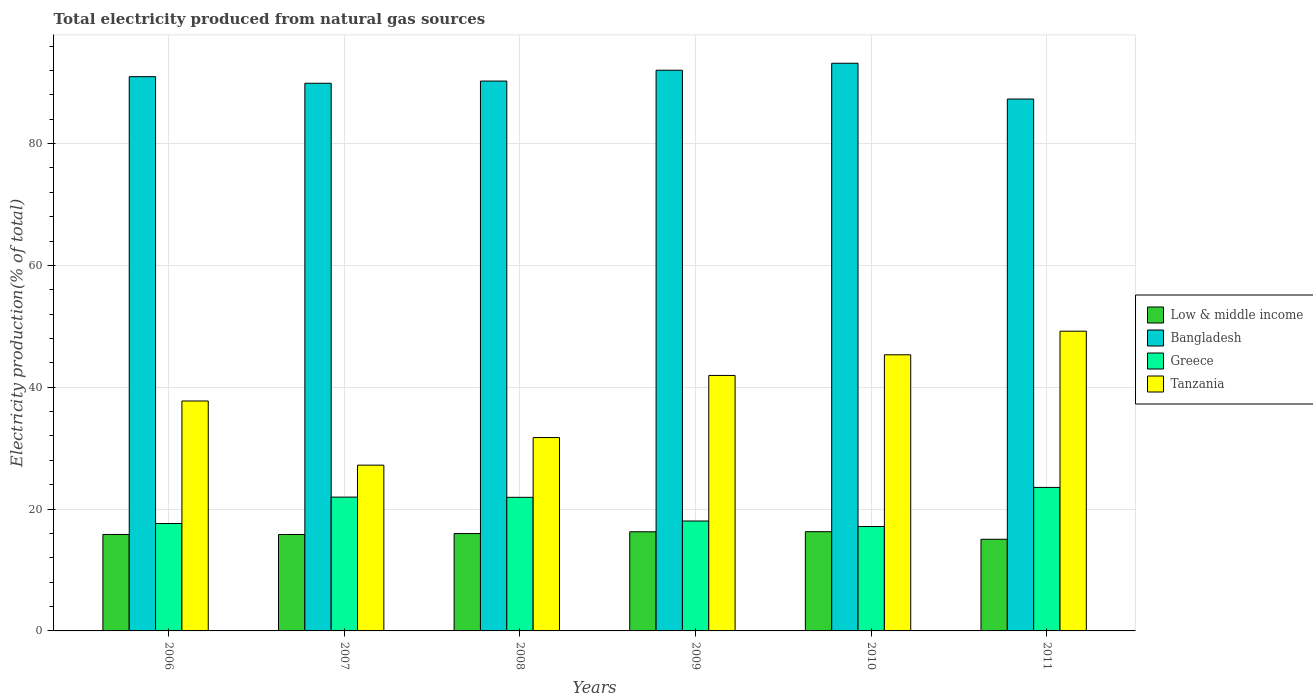How many different coloured bars are there?
Offer a terse response. 4. How many groups of bars are there?
Provide a succinct answer. 6. Are the number of bars per tick equal to the number of legend labels?
Your response must be concise. Yes. Are the number of bars on each tick of the X-axis equal?
Provide a succinct answer. Yes. What is the label of the 4th group of bars from the left?
Provide a short and direct response. 2009. What is the total electricity produced in Low & middle income in 2011?
Make the answer very short. 15.04. Across all years, what is the maximum total electricity produced in Bangladesh?
Give a very brief answer. 93.18. Across all years, what is the minimum total electricity produced in Tanzania?
Provide a succinct answer. 27.21. What is the total total electricity produced in Greece in the graph?
Your response must be concise. 120.26. What is the difference between the total electricity produced in Low & middle income in 2006 and that in 2008?
Keep it short and to the point. -0.15. What is the difference between the total electricity produced in Low & middle income in 2009 and the total electricity produced in Tanzania in 2006?
Your answer should be compact. -21.47. What is the average total electricity produced in Greece per year?
Offer a terse response. 20.04. In the year 2011, what is the difference between the total electricity produced in Bangladesh and total electricity produced in Tanzania?
Provide a short and direct response. 38.11. In how many years, is the total electricity produced in Greece greater than 80 %?
Give a very brief answer. 0. What is the ratio of the total electricity produced in Low & middle income in 2007 to that in 2008?
Give a very brief answer. 0.99. Is the difference between the total electricity produced in Bangladesh in 2009 and 2011 greater than the difference between the total electricity produced in Tanzania in 2009 and 2011?
Give a very brief answer. Yes. What is the difference between the highest and the second highest total electricity produced in Low & middle income?
Your answer should be compact. 0.01. What is the difference between the highest and the lowest total electricity produced in Low & middle income?
Offer a very short reply. 1.25. In how many years, is the total electricity produced in Bangladesh greater than the average total electricity produced in Bangladesh taken over all years?
Keep it short and to the point. 3. Is the sum of the total electricity produced in Greece in 2008 and 2011 greater than the maximum total electricity produced in Tanzania across all years?
Provide a succinct answer. No. What does the 3rd bar from the left in 2006 represents?
Keep it short and to the point. Greece. What does the 1st bar from the right in 2011 represents?
Your answer should be compact. Tanzania. Is it the case that in every year, the sum of the total electricity produced in Low & middle income and total electricity produced in Bangladesh is greater than the total electricity produced in Tanzania?
Offer a terse response. Yes. How many bars are there?
Give a very brief answer. 24. Are all the bars in the graph horizontal?
Provide a short and direct response. No. How many years are there in the graph?
Ensure brevity in your answer.  6. Does the graph contain any zero values?
Make the answer very short. No. Where does the legend appear in the graph?
Your answer should be very brief. Center right. How are the legend labels stacked?
Your answer should be very brief. Vertical. What is the title of the graph?
Offer a terse response. Total electricity produced from natural gas sources. What is the label or title of the X-axis?
Ensure brevity in your answer.  Years. What is the Electricity production(% of total) in Low & middle income in 2006?
Provide a short and direct response. 15.83. What is the Electricity production(% of total) of Bangladesh in 2006?
Your answer should be very brief. 90.98. What is the Electricity production(% of total) in Greece in 2006?
Make the answer very short. 17.63. What is the Electricity production(% of total) of Tanzania in 2006?
Provide a succinct answer. 37.74. What is the Electricity production(% of total) of Low & middle income in 2007?
Your answer should be compact. 15.83. What is the Electricity production(% of total) in Bangladesh in 2007?
Give a very brief answer. 89.9. What is the Electricity production(% of total) in Greece in 2007?
Offer a very short reply. 21.96. What is the Electricity production(% of total) of Tanzania in 2007?
Your response must be concise. 27.21. What is the Electricity production(% of total) of Low & middle income in 2008?
Your answer should be compact. 15.99. What is the Electricity production(% of total) in Bangladesh in 2008?
Keep it short and to the point. 90.26. What is the Electricity production(% of total) of Greece in 2008?
Offer a terse response. 21.93. What is the Electricity production(% of total) of Tanzania in 2008?
Offer a terse response. 31.74. What is the Electricity production(% of total) of Low & middle income in 2009?
Your answer should be very brief. 16.27. What is the Electricity production(% of total) of Bangladesh in 2009?
Offer a very short reply. 92.03. What is the Electricity production(% of total) of Greece in 2009?
Keep it short and to the point. 18.04. What is the Electricity production(% of total) of Tanzania in 2009?
Give a very brief answer. 41.93. What is the Electricity production(% of total) in Low & middle income in 2010?
Provide a succinct answer. 16.29. What is the Electricity production(% of total) in Bangladesh in 2010?
Your response must be concise. 93.18. What is the Electricity production(% of total) in Greece in 2010?
Ensure brevity in your answer.  17.14. What is the Electricity production(% of total) of Tanzania in 2010?
Your answer should be very brief. 45.32. What is the Electricity production(% of total) in Low & middle income in 2011?
Keep it short and to the point. 15.04. What is the Electricity production(% of total) in Bangladesh in 2011?
Provide a succinct answer. 87.31. What is the Electricity production(% of total) in Greece in 2011?
Offer a very short reply. 23.56. What is the Electricity production(% of total) in Tanzania in 2011?
Provide a short and direct response. 49.2. Across all years, what is the maximum Electricity production(% of total) in Low & middle income?
Make the answer very short. 16.29. Across all years, what is the maximum Electricity production(% of total) in Bangladesh?
Your answer should be compact. 93.18. Across all years, what is the maximum Electricity production(% of total) of Greece?
Offer a very short reply. 23.56. Across all years, what is the maximum Electricity production(% of total) of Tanzania?
Provide a short and direct response. 49.2. Across all years, what is the minimum Electricity production(% of total) of Low & middle income?
Your answer should be compact. 15.04. Across all years, what is the minimum Electricity production(% of total) of Bangladesh?
Make the answer very short. 87.31. Across all years, what is the minimum Electricity production(% of total) of Greece?
Keep it short and to the point. 17.14. Across all years, what is the minimum Electricity production(% of total) of Tanzania?
Your answer should be compact. 27.21. What is the total Electricity production(% of total) in Low & middle income in the graph?
Ensure brevity in your answer.  95.25. What is the total Electricity production(% of total) of Bangladesh in the graph?
Give a very brief answer. 543.65. What is the total Electricity production(% of total) in Greece in the graph?
Provide a succinct answer. 120.26. What is the total Electricity production(% of total) in Tanzania in the graph?
Give a very brief answer. 233.15. What is the difference between the Electricity production(% of total) in Low & middle income in 2006 and that in 2007?
Offer a terse response. 0.01. What is the difference between the Electricity production(% of total) in Greece in 2006 and that in 2007?
Give a very brief answer. -4.33. What is the difference between the Electricity production(% of total) in Tanzania in 2006 and that in 2007?
Make the answer very short. 10.53. What is the difference between the Electricity production(% of total) in Low & middle income in 2006 and that in 2008?
Your response must be concise. -0.15. What is the difference between the Electricity production(% of total) of Bangladesh in 2006 and that in 2008?
Offer a terse response. 0.72. What is the difference between the Electricity production(% of total) in Greece in 2006 and that in 2008?
Offer a terse response. -4.3. What is the difference between the Electricity production(% of total) in Tanzania in 2006 and that in 2008?
Offer a very short reply. 6.01. What is the difference between the Electricity production(% of total) of Low & middle income in 2006 and that in 2009?
Your response must be concise. -0.44. What is the difference between the Electricity production(% of total) in Bangladesh in 2006 and that in 2009?
Ensure brevity in your answer.  -1.06. What is the difference between the Electricity production(% of total) of Greece in 2006 and that in 2009?
Offer a terse response. -0.41. What is the difference between the Electricity production(% of total) of Tanzania in 2006 and that in 2009?
Offer a terse response. -4.19. What is the difference between the Electricity production(% of total) in Low & middle income in 2006 and that in 2010?
Offer a terse response. -0.46. What is the difference between the Electricity production(% of total) in Bangladesh in 2006 and that in 2010?
Offer a terse response. -2.2. What is the difference between the Electricity production(% of total) in Greece in 2006 and that in 2010?
Your answer should be compact. 0.5. What is the difference between the Electricity production(% of total) in Tanzania in 2006 and that in 2010?
Your answer should be compact. -7.58. What is the difference between the Electricity production(% of total) of Low & middle income in 2006 and that in 2011?
Make the answer very short. 0.79. What is the difference between the Electricity production(% of total) of Bangladesh in 2006 and that in 2011?
Keep it short and to the point. 3.67. What is the difference between the Electricity production(% of total) in Greece in 2006 and that in 2011?
Ensure brevity in your answer.  -5.92. What is the difference between the Electricity production(% of total) of Tanzania in 2006 and that in 2011?
Provide a short and direct response. -11.46. What is the difference between the Electricity production(% of total) in Low & middle income in 2007 and that in 2008?
Offer a terse response. -0.16. What is the difference between the Electricity production(% of total) in Bangladesh in 2007 and that in 2008?
Make the answer very short. -0.36. What is the difference between the Electricity production(% of total) of Greece in 2007 and that in 2008?
Your answer should be compact. 0.03. What is the difference between the Electricity production(% of total) of Tanzania in 2007 and that in 2008?
Keep it short and to the point. -4.53. What is the difference between the Electricity production(% of total) in Low & middle income in 2007 and that in 2009?
Offer a terse response. -0.45. What is the difference between the Electricity production(% of total) of Bangladesh in 2007 and that in 2009?
Offer a very short reply. -2.14. What is the difference between the Electricity production(% of total) of Greece in 2007 and that in 2009?
Ensure brevity in your answer.  3.92. What is the difference between the Electricity production(% of total) of Tanzania in 2007 and that in 2009?
Provide a short and direct response. -14.72. What is the difference between the Electricity production(% of total) of Low & middle income in 2007 and that in 2010?
Your response must be concise. -0.46. What is the difference between the Electricity production(% of total) in Bangladesh in 2007 and that in 2010?
Provide a succinct answer. -3.28. What is the difference between the Electricity production(% of total) in Greece in 2007 and that in 2010?
Your answer should be very brief. 4.83. What is the difference between the Electricity production(% of total) of Tanzania in 2007 and that in 2010?
Your answer should be very brief. -18.11. What is the difference between the Electricity production(% of total) in Low & middle income in 2007 and that in 2011?
Provide a succinct answer. 0.78. What is the difference between the Electricity production(% of total) in Bangladesh in 2007 and that in 2011?
Your response must be concise. 2.59. What is the difference between the Electricity production(% of total) in Greece in 2007 and that in 2011?
Your answer should be very brief. -1.59. What is the difference between the Electricity production(% of total) of Tanzania in 2007 and that in 2011?
Keep it short and to the point. -21.99. What is the difference between the Electricity production(% of total) in Low & middle income in 2008 and that in 2009?
Ensure brevity in your answer.  -0.29. What is the difference between the Electricity production(% of total) of Bangladesh in 2008 and that in 2009?
Offer a very short reply. -1.78. What is the difference between the Electricity production(% of total) of Greece in 2008 and that in 2009?
Give a very brief answer. 3.89. What is the difference between the Electricity production(% of total) of Tanzania in 2008 and that in 2009?
Give a very brief answer. -10.2. What is the difference between the Electricity production(% of total) in Low & middle income in 2008 and that in 2010?
Your answer should be compact. -0.3. What is the difference between the Electricity production(% of total) of Bangladesh in 2008 and that in 2010?
Ensure brevity in your answer.  -2.92. What is the difference between the Electricity production(% of total) of Greece in 2008 and that in 2010?
Offer a terse response. 4.8. What is the difference between the Electricity production(% of total) of Tanzania in 2008 and that in 2010?
Your response must be concise. -13.59. What is the difference between the Electricity production(% of total) in Low & middle income in 2008 and that in 2011?
Offer a very short reply. 0.94. What is the difference between the Electricity production(% of total) of Bangladesh in 2008 and that in 2011?
Provide a short and direct response. 2.95. What is the difference between the Electricity production(% of total) in Greece in 2008 and that in 2011?
Offer a very short reply. -1.62. What is the difference between the Electricity production(% of total) of Tanzania in 2008 and that in 2011?
Keep it short and to the point. -17.46. What is the difference between the Electricity production(% of total) in Low & middle income in 2009 and that in 2010?
Your response must be concise. -0.01. What is the difference between the Electricity production(% of total) of Bangladesh in 2009 and that in 2010?
Offer a terse response. -1.14. What is the difference between the Electricity production(% of total) in Greece in 2009 and that in 2010?
Ensure brevity in your answer.  0.91. What is the difference between the Electricity production(% of total) in Tanzania in 2009 and that in 2010?
Offer a terse response. -3.39. What is the difference between the Electricity production(% of total) in Low & middle income in 2009 and that in 2011?
Keep it short and to the point. 1.23. What is the difference between the Electricity production(% of total) in Bangladesh in 2009 and that in 2011?
Make the answer very short. 4.73. What is the difference between the Electricity production(% of total) in Greece in 2009 and that in 2011?
Give a very brief answer. -5.51. What is the difference between the Electricity production(% of total) in Tanzania in 2009 and that in 2011?
Provide a succinct answer. -7.26. What is the difference between the Electricity production(% of total) of Low & middle income in 2010 and that in 2011?
Your answer should be very brief. 1.25. What is the difference between the Electricity production(% of total) in Bangladesh in 2010 and that in 2011?
Offer a very short reply. 5.87. What is the difference between the Electricity production(% of total) of Greece in 2010 and that in 2011?
Offer a terse response. -6.42. What is the difference between the Electricity production(% of total) of Tanzania in 2010 and that in 2011?
Provide a succinct answer. -3.87. What is the difference between the Electricity production(% of total) of Low & middle income in 2006 and the Electricity production(% of total) of Bangladesh in 2007?
Give a very brief answer. -74.06. What is the difference between the Electricity production(% of total) in Low & middle income in 2006 and the Electricity production(% of total) in Greece in 2007?
Provide a short and direct response. -6.13. What is the difference between the Electricity production(% of total) of Low & middle income in 2006 and the Electricity production(% of total) of Tanzania in 2007?
Your answer should be very brief. -11.38. What is the difference between the Electricity production(% of total) of Bangladesh in 2006 and the Electricity production(% of total) of Greece in 2007?
Give a very brief answer. 69.01. What is the difference between the Electricity production(% of total) in Bangladesh in 2006 and the Electricity production(% of total) in Tanzania in 2007?
Your answer should be compact. 63.77. What is the difference between the Electricity production(% of total) of Greece in 2006 and the Electricity production(% of total) of Tanzania in 2007?
Give a very brief answer. -9.58. What is the difference between the Electricity production(% of total) of Low & middle income in 2006 and the Electricity production(% of total) of Bangladesh in 2008?
Offer a very short reply. -74.43. What is the difference between the Electricity production(% of total) of Low & middle income in 2006 and the Electricity production(% of total) of Greece in 2008?
Your response must be concise. -6.1. What is the difference between the Electricity production(% of total) of Low & middle income in 2006 and the Electricity production(% of total) of Tanzania in 2008?
Your answer should be very brief. -15.9. What is the difference between the Electricity production(% of total) in Bangladesh in 2006 and the Electricity production(% of total) in Greece in 2008?
Offer a terse response. 69.05. What is the difference between the Electricity production(% of total) in Bangladesh in 2006 and the Electricity production(% of total) in Tanzania in 2008?
Your answer should be very brief. 59.24. What is the difference between the Electricity production(% of total) in Greece in 2006 and the Electricity production(% of total) in Tanzania in 2008?
Ensure brevity in your answer.  -14.11. What is the difference between the Electricity production(% of total) in Low & middle income in 2006 and the Electricity production(% of total) in Bangladesh in 2009?
Offer a terse response. -76.2. What is the difference between the Electricity production(% of total) of Low & middle income in 2006 and the Electricity production(% of total) of Greece in 2009?
Provide a succinct answer. -2.21. What is the difference between the Electricity production(% of total) in Low & middle income in 2006 and the Electricity production(% of total) in Tanzania in 2009?
Make the answer very short. -26.1. What is the difference between the Electricity production(% of total) of Bangladesh in 2006 and the Electricity production(% of total) of Greece in 2009?
Offer a terse response. 72.93. What is the difference between the Electricity production(% of total) of Bangladesh in 2006 and the Electricity production(% of total) of Tanzania in 2009?
Your answer should be very brief. 49.04. What is the difference between the Electricity production(% of total) of Greece in 2006 and the Electricity production(% of total) of Tanzania in 2009?
Make the answer very short. -24.3. What is the difference between the Electricity production(% of total) in Low & middle income in 2006 and the Electricity production(% of total) in Bangladesh in 2010?
Ensure brevity in your answer.  -77.35. What is the difference between the Electricity production(% of total) in Low & middle income in 2006 and the Electricity production(% of total) in Greece in 2010?
Provide a short and direct response. -1.3. What is the difference between the Electricity production(% of total) of Low & middle income in 2006 and the Electricity production(% of total) of Tanzania in 2010?
Your answer should be very brief. -29.49. What is the difference between the Electricity production(% of total) of Bangladesh in 2006 and the Electricity production(% of total) of Greece in 2010?
Make the answer very short. 73.84. What is the difference between the Electricity production(% of total) of Bangladesh in 2006 and the Electricity production(% of total) of Tanzania in 2010?
Your answer should be very brief. 45.65. What is the difference between the Electricity production(% of total) of Greece in 2006 and the Electricity production(% of total) of Tanzania in 2010?
Your answer should be very brief. -27.69. What is the difference between the Electricity production(% of total) in Low & middle income in 2006 and the Electricity production(% of total) in Bangladesh in 2011?
Provide a short and direct response. -71.47. What is the difference between the Electricity production(% of total) of Low & middle income in 2006 and the Electricity production(% of total) of Greece in 2011?
Your answer should be very brief. -7.72. What is the difference between the Electricity production(% of total) in Low & middle income in 2006 and the Electricity production(% of total) in Tanzania in 2011?
Offer a very short reply. -33.37. What is the difference between the Electricity production(% of total) in Bangladesh in 2006 and the Electricity production(% of total) in Greece in 2011?
Your answer should be very brief. 67.42. What is the difference between the Electricity production(% of total) in Bangladesh in 2006 and the Electricity production(% of total) in Tanzania in 2011?
Provide a succinct answer. 41.78. What is the difference between the Electricity production(% of total) of Greece in 2006 and the Electricity production(% of total) of Tanzania in 2011?
Your answer should be very brief. -31.57. What is the difference between the Electricity production(% of total) of Low & middle income in 2007 and the Electricity production(% of total) of Bangladesh in 2008?
Provide a short and direct response. -74.43. What is the difference between the Electricity production(% of total) of Low & middle income in 2007 and the Electricity production(% of total) of Greece in 2008?
Ensure brevity in your answer.  -6.1. What is the difference between the Electricity production(% of total) in Low & middle income in 2007 and the Electricity production(% of total) in Tanzania in 2008?
Offer a terse response. -15.91. What is the difference between the Electricity production(% of total) in Bangladesh in 2007 and the Electricity production(% of total) in Greece in 2008?
Ensure brevity in your answer.  67.97. What is the difference between the Electricity production(% of total) in Bangladesh in 2007 and the Electricity production(% of total) in Tanzania in 2008?
Make the answer very short. 58.16. What is the difference between the Electricity production(% of total) of Greece in 2007 and the Electricity production(% of total) of Tanzania in 2008?
Provide a short and direct response. -9.77. What is the difference between the Electricity production(% of total) in Low & middle income in 2007 and the Electricity production(% of total) in Bangladesh in 2009?
Ensure brevity in your answer.  -76.21. What is the difference between the Electricity production(% of total) of Low & middle income in 2007 and the Electricity production(% of total) of Greece in 2009?
Make the answer very short. -2.22. What is the difference between the Electricity production(% of total) in Low & middle income in 2007 and the Electricity production(% of total) in Tanzania in 2009?
Keep it short and to the point. -26.11. What is the difference between the Electricity production(% of total) of Bangladesh in 2007 and the Electricity production(% of total) of Greece in 2009?
Offer a terse response. 71.85. What is the difference between the Electricity production(% of total) in Bangladesh in 2007 and the Electricity production(% of total) in Tanzania in 2009?
Your answer should be compact. 47.96. What is the difference between the Electricity production(% of total) in Greece in 2007 and the Electricity production(% of total) in Tanzania in 2009?
Your response must be concise. -19.97. What is the difference between the Electricity production(% of total) in Low & middle income in 2007 and the Electricity production(% of total) in Bangladesh in 2010?
Offer a terse response. -77.35. What is the difference between the Electricity production(% of total) in Low & middle income in 2007 and the Electricity production(% of total) in Greece in 2010?
Provide a succinct answer. -1.31. What is the difference between the Electricity production(% of total) of Low & middle income in 2007 and the Electricity production(% of total) of Tanzania in 2010?
Make the answer very short. -29.5. What is the difference between the Electricity production(% of total) in Bangladesh in 2007 and the Electricity production(% of total) in Greece in 2010?
Offer a very short reply. 72.76. What is the difference between the Electricity production(% of total) of Bangladesh in 2007 and the Electricity production(% of total) of Tanzania in 2010?
Give a very brief answer. 44.57. What is the difference between the Electricity production(% of total) of Greece in 2007 and the Electricity production(% of total) of Tanzania in 2010?
Ensure brevity in your answer.  -23.36. What is the difference between the Electricity production(% of total) of Low & middle income in 2007 and the Electricity production(% of total) of Bangladesh in 2011?
Your answer should be compact. -71.48. What is the difference between the Electricity production(% of total) of Low & middle income in 2007 and the Electricity production(% of total) of Greece in 2011?
Make the answer very short. -7.73. What is the difference between the Electricity production(% of total) in Low & middle income in 2007 and the Electricity production(% of total) in Tanzania in 2011?
Your answer should be very brief. -33.37. What is the difference between the Electricity production(% of total) of Bangladesh in 2007 and the Electricity production(% of total) of Greece in 2011?
Your answer should be compact. 66.34. What is the difference between the Electricity production(% of total) of Bangladesh in 2007 and the Electricity production(% of total) of Tanzania in 2011?
Offer a very short reply. 40.7. What is the difference between the Electricity production(% of total) in Greece in 2007 and the Electricity production(% of total) in Tanzania in 2011?
Provide a short and direct response. -27.23. What is the difference between the Electricity production(% of total) of Low & middle income in 2008 and the Electricity production(% of total) of Bangladesh in 2009?
Ensure brevity in your answer.  -76.05. What is the difference between the Electricity production(% of total) in Low & middle income in 2008 and the Electricity production(% of total) in Greece in 2009?
Make the answer very short. -2.06. What is the difference between the Electricity production(% of total) in Low & middle income in 2008 and the Electricity production(% of total) in Tanzania in 2009?
Provide a succinct answer. -25.95. What is the difference between the Electricity production(% of total) in Bangladesh in 2008 and the Electricity production(% of total) in Greece in 2009?
Your response must be concise. 72.22. What is the difference between the Electricity production(% of total) in Bangladesh in 2008 and the Electricity production(% of total) in Tanzania in 2009?
Your answer should be very brief. 48.32. What is the difference between the Electricity production(% of total) of Greece in 2008 and the Electricity production(% of total) of Tanzania in 2009?
Provide a succinct answer. -20. What is the difference between the Electricity production(% of total) of Low & middle income in 2008 and the Electricity production(% of total) of Bangladesh in 2010?
Give a very brief answer. -77.19. What is the difference between the Electricity production(% of total) in Low & middle income in 2008 and the Electricity production(% of total) in Greece in 2010?
Provide a succinct answer. -1.15. What is the difference between the Electricity production(% of total) of Low & middle income in 2008 and the Electricity production(% of total) of Tanzania in 2010?
Your response must be concise. -29.34. What is the difference between the Electricity production(% of total) of Bangladesh in 2008 and the Electricity production(% of total) of Greece in 2010?
Make the answer very short. 73.12. What is the difference between the Electricity production(% of total) of Bangladesh in 2008 and the Electricity production(% of total) of Tanzania in 2010?
Your response must be concise. 44.93. What is the difference between the Electricity production(% of total) of Greece in 2008 and the Electricity production(% of total) of Tanzania in 2010?
Provide a short and direct response. -23.39. What is the difference between the Electricity production(% of total) of Low & middle income in 2008 and the Electricity production(% of total) of Bangladesh in 2011?
Provide a short and direct response. -71.32. What is the difference between the Electricity production(% of total) of Low & middle income in 2008 and the Electricity production(% of total) of Greece in 2011?
Ensure brevity in your answer.  -7.57. What is the difference between the Electricity production(% of total) in Low & middle income in 2008 and the Electricity production(% of total) in Tanzania in 2011?
Provide a short and direct response. -33.21. What is the difference between the Electricity production(% of total) in Bangladesh in 2008 and the Electricity production(% of total) in Greece in 2011?
Your answer should be compact. 66.7. What is the difference between the Electricity production(% of total) of Bangladesh in 2008 and the Electricity production(% of total) of Tanzania in 2011?
Ensure brevity in your answer.  41.06. What is the difference between the Electricity production(% of total) of Greece in 2008 and the Electricity production(% of total) of Tanzania in 2011?
Offer a very short reply. -27.27. What is the difference between the Electricity production(% of total) of Low & middle income in 2009 and the Electricity production(% of total) of Bangladesh in 2010?
Ensure brevity in your answer.  -76.9. What is the difference between the Electricity production(% of total) in Low & middle income in 2009 and the Electricity production(% of total) in Greece in 2010?
Your answer should be very brief. -0.86. What is the difference between the Electricity production(% of total) of Low & middle income in 2009 and the Electricity production(% of total) of Tanzania in 2010?
Ensure brevity in your answer.  -29.05. What is the difference between the Electricity production(% of total) of Bangladesh in 2009 and the Electricity production(% of total) of Greece in 2010?
Offer a terse response. 74.9. What is the difference between the Electricity production(% of total) of Bangladesh in 2009 and the Electricity production(% of total) of Tanzania in 2010?
Ensure brevity in your answer.  46.71. What is the difference between the Electricity production(% of total) of Greece in 2009 and the Electricity production(% of total) of Tanzania in 2010?
Give a very brief answer. -27.28. What is the difference between the Electricity production(% of total) in Low & middle income in 2009 and the Electricity production(% of total) in Bangladesh in 2011?
Keep it short and to the point. -71.03. What is the difference between the Electricity production(% of total) of Low & middle income in 2009 and the Electricity production(% of total) of Greece in 2011?
Offer a terse response. -7.28. What is the difference between the Electricity production(% of total) in Low & middle income in 2009 and the Electricity production(% of total) in Tanzania in 2011?
Give a very brief answer. -32.92. What is the difference between the Electricity production(% of total) of Bangladesh in 2009 and the Electricity production(% of total) of Greece in 2011?
Give a very brief answer. 68.48. What is the difference between the Electricity production(% of total) of Bangladesh in 2009 and the Electricity production(% of total) of Tanzania in 2011?
Your answer should be very brief. 42.84. What is the difference between the Electricity production(% of total) of Greece in 2009 and the Electricity production(% of total) of Tanzania in 2011?
Your answer should be compact. -31.16. What is the difference between the Electricity production(% of total) in Low & middle income in 2010 and the Electricity production(% of total) in Bangladesh in 2011?
Offer a very short reply. -71.02. What is the difference between the Electricity production(% of total) of Low & middle income in 2010 and the Electricity production(% of total) of Greece in 2011?
Your answer should be very brief. -7.27. What is the difference between the Electricity production(% of total) in Low & middle income in 2010 and the Electricity production(% of total) in Tanzania in 2011?
Give a very brief answer. -32.91. What is the difference between the Electricity production(% of total) of Bangladesh in 2010 and the Electricity production(% of total) of Greece in 2011?
Ensure brevity in your answer.  69.62. What is the difference between the Electricity production(% of total) of Bangladesh in 2010 and the Electricity production(% of total) of Tanzania in 2011?
Your answer should be very brief. 43.98. What is the difference between the Electricity production(% of total) of Greece in 2010 and the Electricity production(% of total) of Tanzania in 2011?
Offer a very short reply. -32.06. What is the average Electricity production(% of total) of Low & middle income per year?
Provide a succinct answer. 15.88. What is the average Electricity production(% of total) in Bangladesh per year?
Give a very brief answer. 90.61. What is the average Electricity production(% of total) of Greece per year?
Provide a succinct answer. 20.04. What is the average Electricity production(% of total) of Tanzania per year?
Provide a succinct answer. 38.86. In the year 2006, what is the difference between the Electricity production(% of total) of Low & middle income and Electricity production(% of total) of Bangladesh?
Your response must be concise. -75.14. In the year 2006, what is the difference between the Electricity production(% of total) of Low & middle income and Electricity production(% of total) of Greece?
Ensure brevity in your answer.  -1.8. In the year 2006, what is the difference between the Electricity production(% of total) of Low & middle income and Electricity production(% of total) of Tanzania?
Give a very brief answer. -21.91. In the year 2006, what is the difference between the Electricity production(% of total) in Bangladesh and Electricity production(% of total) in Greece?
Offer a very short reply. 73.35. In the year 2006, what is the difference between the Electricity production(% of total) of Bangladesh and Electricity production(% of total) of Tanzania?
Give a very brief answer. 53.23. In the year 2006, what is the difference between the Electricity production(% of total) in Greece and Electricity production(% of total) in Tanzania?
Your response must be concise. -20.11. In the year 2007, what is the difference between the Electricity production(% of total) in Low & middle income and Electricity production(% of total) in Bangladesh?
Your answer should be very brief. -74.07. In the year 2007, what is the difference between the Electricity production(% of total) in Low & middle income and Electricity production(% of total) in Greece?
Your answer should be very brief. -6.14. In the year 2007, what is the difference between the Electricity production(% of total) of Low & middle income and Electricity production(% of total) of Tanzania?
Offer a very short reply. -11.39. In the year 2007, what is the difference between the Electricity production(% of total) of Bangladesh and Electricity production(% of total) of Greece?
Offer a terse response. 67.93. In the year 2007, what is the difference between the Electricity production(% of total) of Bangladesh and Electricity production(% of total) of Tanzania?
Offer a very short reply. 62.69. In the year 2007, what is the difference between the Electricity production(% of total) of Greece and Electricity production(% of total) of Tanzania?
Your answer should be compact. -5.25. In the year 2008, what is the difference between the Electricity production(% of total) of Low & middle income and Electricity production(% of total) of Bangladesh?
Provide a succinct answer. -74.27. In the year 2008, what is the difference between the Electricity production(% of total) in Low & middle income and Electricity production(% of total) in Greece?
Your answer should be compact. -5.95. In the year 2008, what is the difference between the Electricity production(% of total) in Low & middle income and Electricity production(% of total) in Tanzania?
Give a very brief answer. -15.75. In the year 2008, what is the difference between the Electricity production(% of total) in Bangladesh and Electricity production(% of total) in Greece?
Offer a very short reply. 68.33. In the year 2008, what is the difference between the Electricity production(% of total) in Bangladesh and Electricity production(% of total) in Tanzania?
Offer a very short reply. 58.52. In the year 2008, what is the difference between the Electricity production(% of total) of Greece and Electricity production(% of total) of Tanzania?
Give a very brief answer. -9.81. In the year 2009, what is the difference between the Electricity production(% of total) in Low & middle income and Electricity production(% of total) in Bangladesh?
Give a very brief answer. -75.76. In the year 2009, what is the difference between the Electricity production(% of total) in Low & middle income and Electricity production(% of total) in Greece?
Offer a terse response. -1.77. In the year 2009, what is the difference between the Electricity production(% of total) in Low & middle income and Electricity production(% of total) in Tanzania?
Your answer should be compact. -25.66. In the year 2009, what is the difference between the Electricity production(% of total) in Bangladesh and Electricity production(% of total) in Greece?
Your response must be concise. 73.99. In the year 2009, what is the difference between the Electricity production(% of total) in Bangladesh and Electricity production(% of total) in Tanzania?
Give a very brief answer. 50.1. In the year 2009, what is the difference between the Electricity production(% of total) in Greece and Electricity production(% of total) in Tanzania?
Your response must be concise. -23.89. In the year 2010, what is the difference between the Electricity production(% of total) of Low & middle income and Electricity production(% of total) of Bangladesh?
Give a very brief answer. -76.89. In the year 2010, what is the difference between the Electricity production(% of total) of Low & middle income and Electricity production(% of total) of Greece?
Provide a short and direct response. -0.85. In the year 2010, what is the difference between the Electricity production(% of total) of Low & middle income and Electricity production(% of total) of Tanzania?
Give a very brief answer. -29.04. In the year 2010, what is the difference between the Electricity production(% of total) of Bangladesh and Electricity production(% of total) of Greece?
Provide a succinct answer. 76.04. In the year 2010, what is the difference between the Electricity production(% of total) of Bangladesh and Electricity production(% of total) of Tanzania?
Offer a terse response. 47.85. In the year 2010, what is the difference between the Electricity production(% of total) of Greece and Electricity production(% of total) of Tanzania?
Keep it short and to the point. -28.19. In the year 2011, what is the difference between the Electricity production(% of total) in Low & middle income and Electricity production(% of total) in Bangladesh?
Offer a very short reply. -72.26. In the year 2011, what is the difference between the Electricity production(% of total) in Low & middle income and Electricity production(% of total) in Greece?
Make the answer very short. -8.51. In the year 2011, what is the difference between the Electricity production(% of total) of Low & middle income and Electricity production(% of total) of Tanzania?
Ensure brevity in your answer.  -34.16. In the year 2011, what is the difference between the Electricity production(% of total) in Bangladesh and Electricity production(% of total) in Greece?
Your response must be concise. 63.75. In the year 2011, what is the difference between the Electricity production(% of total) of Bangladesh and Electricity production(% of total) of Tanzania?
Keep it short and to the point. 38.11. In the year 2011, what is the difference between the Electricity production(% of total) of Greece and Electricity production(% of total) of Tanzania?
Offer a very short reply. -25.64. What is the ratio of the Electricity production(% of total) of Low & middle income in 2006 to that in 2007?
Provide a succinct answer. 1. What is the ratio of the Electricity production(% of total) in Greece in 2006 to that in 2007?
Your answer should be compact. 0.8. What is the ratio of the Electricity production(% of total) of Tanzania in 2006 to that in 2007?
Ensure brevity in your answer.  1.39. What is the ratio of the Electricity production(% of total) in Bangladesh in 2006 to that in 2008?
Keep it short and to the point. 1.01. What is the ratio of the Electricity production(% of total) in Greece in 2006 to that in 2008?
Ensure brevity in your answer.  0.8. What is the ratio of the Electricity production(% of total) of Tanzania in 2006 to that in 2008?
Your response must be concise. 1.19. What is the ratio of the Electricity production(% of total) in Low & middle income in 2006 to that in 2009?
Give a very brief answer. 0.97. What is the ratio of the Electricity production(% of total) in Bangladesh in 2006 to that in 2009?
Provide a short and direct response. 0.99. What is the ratio of the Electricity production(% of total) in Greece in 2006 to that in 2009?
Keep it short and to the point. 0.98. What is the ratio of the Electricity production(% of total) in Tanzania in 2006 to that in 2009?
Provide a short and direct response. 0.9. What is the ratio of the Electricity production(% of total) in Bangladesh in 2006 to that in 2010?
Offer a very short reply. 0.98. What is the ratio of the Electricity production(% of total) of Greece in 2006 to that in 2010?
Your answer should be compact. 1.03. What is the ratio of the Electricity production(% of total) of Tanzania in 2006 to that in 2010?
Offer a very short reply. 0.83. What is the ratio of the Electricity production(% of total) of Low & middle income in 2006 to that in 2011?
Offer a very short reply. 1.05. What is the ratio of the Electricity production(% of total) of Bangladesh in 2006 to that in 2011?
Ensure brevity in your answer.  1.04. What is the ratio of the Electricity production(% of total) of Greece in 2006 to that in 2011?
Your answer should be very brief. 0.75. What is the ratio of the Electricity production(% of total) in Tanzania in 2006 to that in 2011?
Your answer should be compact. 0.77. What is the ratio of the Electricity production(% of total) of Low & middle income in 2007 to that in 2008?
Your answer should be very brief. 0.99. What is the ratio of the Electricity production(% of total) in Tanzania in 2007 to that in 2008?
Make the answer very short. 0.86. What is the ratio of the Electricity production(% of total) of Low & middle income in 2007 to that in 2009?
Your answer should be very brief. 0.97. What is the ratio of the Electricity production(% of total) of Bangladesh in 2007 to that in 2009?
Give a very brief answer. 0.98. What is the ratio of the Electricity production(% of total) of Greece in 2007 to that in 2009?
Your answer should be very brief. 1.22. What is the ratio of the Electricity production(% of total) of Tanzania in 2007 to that in 2009?
Offer a terse response. 0.65. What is the ratio of the Electricity production(% of total) in Low & middle income in 2007 to that in 2010?
Offer a terse response. 0.97. What is the ratio of the Electricity production(% of total) of Bangladesh in 2007 to that in 2010?
Make the answer very short. 0.96. What is the ratio of the Electricity production(% of total) in Greece in 2007 to that in 2010?
Offer a terse response. 1.28. What is the ratio of the Electricity production(% of total) in Tanzania in 2007 to that in 2010?
Make the answer very short. 0.6. What is the ratio of the Electricity production(% of total) in Low & middle income in 2007 to that in 2011?
Provide a short and direct response. 1.05. What is the ratio of the Electricity production(% of total) of Bangladesh in 2007 to that in 2011?
Offer a terse response. 1.03. What is the ratio of the Electricity production(% of total) of Greece in 2007 to that in 2011?
Your response must be concise. 0.93. What is the ratio of the Electricity production(% of total) in Tanzania in 2007 to that in 2011?
Your response must be concise. 0.55. What is the ratio of the Electricity production(% of total) of Low & middle income in 2008 to that in 2009?
Offer a very short reply. 0.98. What is the ratio of the Electricity production(% of total) in Bangladesh in 2008 to that in 2009?
Your answer should be very brief. 0.98. What is the ratio of the Electricity production(% of total) of Greece in 2008 to that in 2009?
Your answer should be compact. 1.22. What is the ratio of the Electricity production(% of total) in Tanzania in 2008 to that in 2009?
Make the answer very short. 0.76. What is the ratio of the Electricity production(% of total) in Low & middle income in 2008 to that in 2010?
Keep it short and to the point. 0.98. What is the ratio of the Electricity production(% of total) in Bangladesh in 2008 to that in 2010?
Ensure brevity in your answer.  0.97. What is the ratio of the Electricity production(% of total) in Greece in 2008 to that in 2010?
Offer a terse response. 1.28. What is the ratio of the Electricity production(% of total) of Tanzania in 2008 to that in 2010?
Ensure brevity in your answer.  0.7. What is the ratio of the Electricity production(% of total) in Low & middle income in 2008 to that in 2011?
Provide a short and direct response. 1.06. What is the ratio of the Electricity production(% of total) in Bangladesh in 2008 to that in 2011?
Ensure brevity in your answer.  1.03. What is the ratio of the Electricity production(% of total) in Greece in 2008 to that in 2011?
Your answer should be very brief. 0.93. What is the ratio of the Electricity production(% of total) of Tanzania in 2008 to that in 2011?
Provide a short and direct response. 0.65. What is the ratio of the Electricity production(% of total) of Greece in 2009 to that in 2010?
Offer a very short reply. 1.05. What is the ratio of the Electricity production(% of total) in Tanzania in 2009 to that in 2010?
Your answer should be very brief. 0.93. What is the ratio of the Electricity production(% of total) in Low & middle income in 2009 to that in 2011?
Your answer should be compact. 1.08. What is the ratio of the Electricity production(% of total) in Bangladesh in 2009 to that in 2011?
Keep it short and to the point. 1.05. What is the ratio of the Electricity production(% of total) of Greece in 2009 to that in 2011?
Ensure brevity in your answer.  0.77. What is the ratio of the Electricity production(% of total) in Tanzania in 2009 to that in 2011?
Offer a terse response. 0.85. What is the ratio of the Electricity production(% of total) in Low & middle income in 2010 to that in 2011?
Ensure brevity in your answer.  1.08. What is the ratio of the Electricity production(% of total) of Bangladesh in 2010 to that in 2011?
Offer a terse response. 1.07. What is the ratio of the Electricity production(% of total) of Greece in 2010 to that in 2011?
Your response must be concise. 0.73. What is the ratio of the Electricity production(% of total) in Tanzania in 2010 to that in 2011?
Your response must be concise. 0.92. What is the difference between the highest and the second highest Electricity production(% of total) in Low & middle income?
Keep it short and to the point. 0.01. What is the difference between the highest and the second highest Electricity production(% of total) of Bangladesh?
Provide a succinct answer. 1.14. What is the difference between the highest and the second highest Electricity production(% of total) in Greece?
Your response must be concise. 1.59. What is the difference between the highest and the second highest Electricity production(% of total) of Tanzania?
Offer a very short reply. 3.87. What is the difference between the highest and the lowest Electricity production(% of total) in Low & middle income?
Offer a terse response. 1.25. What is the difference between the highest and the lowest Electricity production(% of total) in Bangladesh?
Your answer should be compact. 5.87. What is the difference between the highest and the lowest Electricity production(% of total) of Greece?
Provide a short and direct response. 6.42. What is the difference between the highest and the lowest Electricity production(% of total) of Tanzania?
Ensure brevity in your answer.  21.99. 